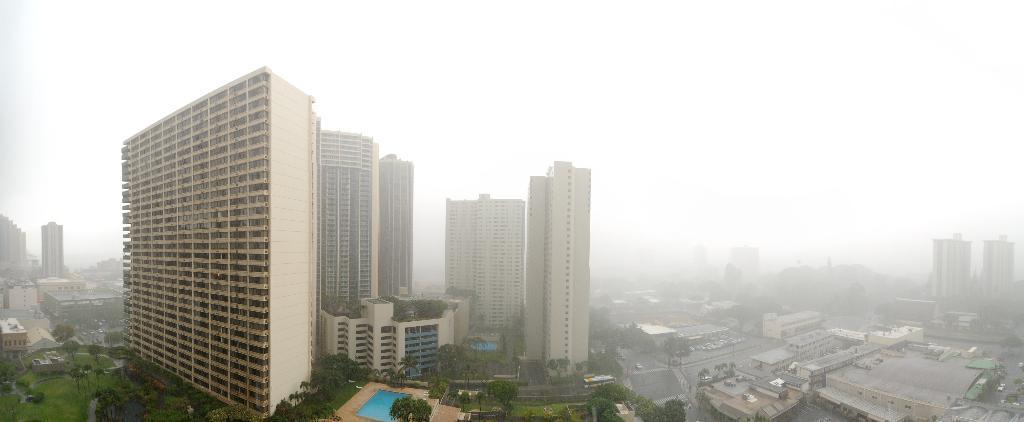In one or two sentences, can you explain what this image depicts? In the foreground I can see grass, trees, swimming pool, buildings, towers, fence, vehicles on the road, fog, light poles and plants. In the background I can see the sky. This image is taken may be during a day. 